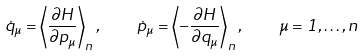<formula> <loc_0><loc_0><loc_500><loc_500>\dot { q } _ { \mu } = \left \langle \frac { \partial H } { \partial p _ { \mu } } \right \rangle _ { n } , \quad \dot { p } _ { \mu } = \left \langle - \frac { \partial H } { \partial q _ { \mu } } \right \rangle _ { n } , \quad \mu = 1 , \dots , n</formula> 